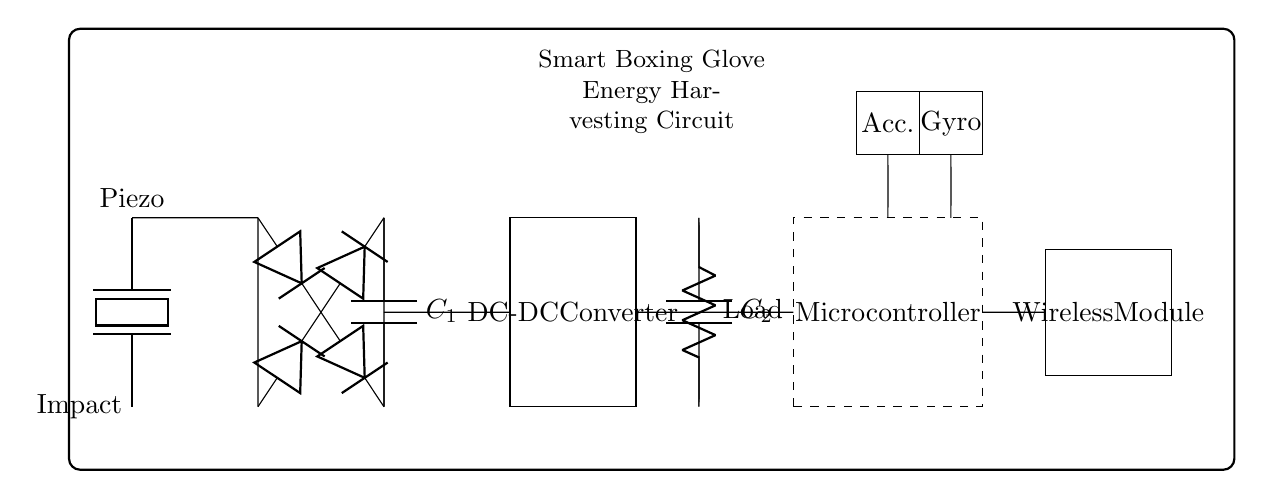What is the main component that converts impact energy? The piezoelectric element is responsible for converting mechanical impact energy into electrical energy in this circuit.
Answer: Piezoelectric What is the purpose of the DC-DC converter in the circuit? The DC-DC converter steps up or steps down the voltage to ensure it is suitable for the load and microcontroller.
Answer: Voltage regulation How many diodes are used in the rectifier section? There are four diodes used to convert the AC voltage generated by the piezoelectric element into a DC voltage.
Answer: Four What are the two types of sensors included in the circuit? The circuit includes an accelerometer and a gyroscope which are used to gather motion and orientation data in the boxing glove.
Answer: Accelerometer and gyroscope What is the function of the output capacitor labeled C2? The output capacitor smooths the voltage output from the DC-DC converter, helping to maintain a steady voltage supply for the load.
Answer: Smoothing voltage What is the primary electrical load in this circuit? The primary electrical load is represented and labeled simply as "Load," which represents the power-consuming component of the energy harvesting system.
Answer: Load What does the wireless module do in this circuit? The wireless module allows the smart boxing gloves to transmit data wirelessly, likely for communication with other devices or applications.
Answer: Data transmission 